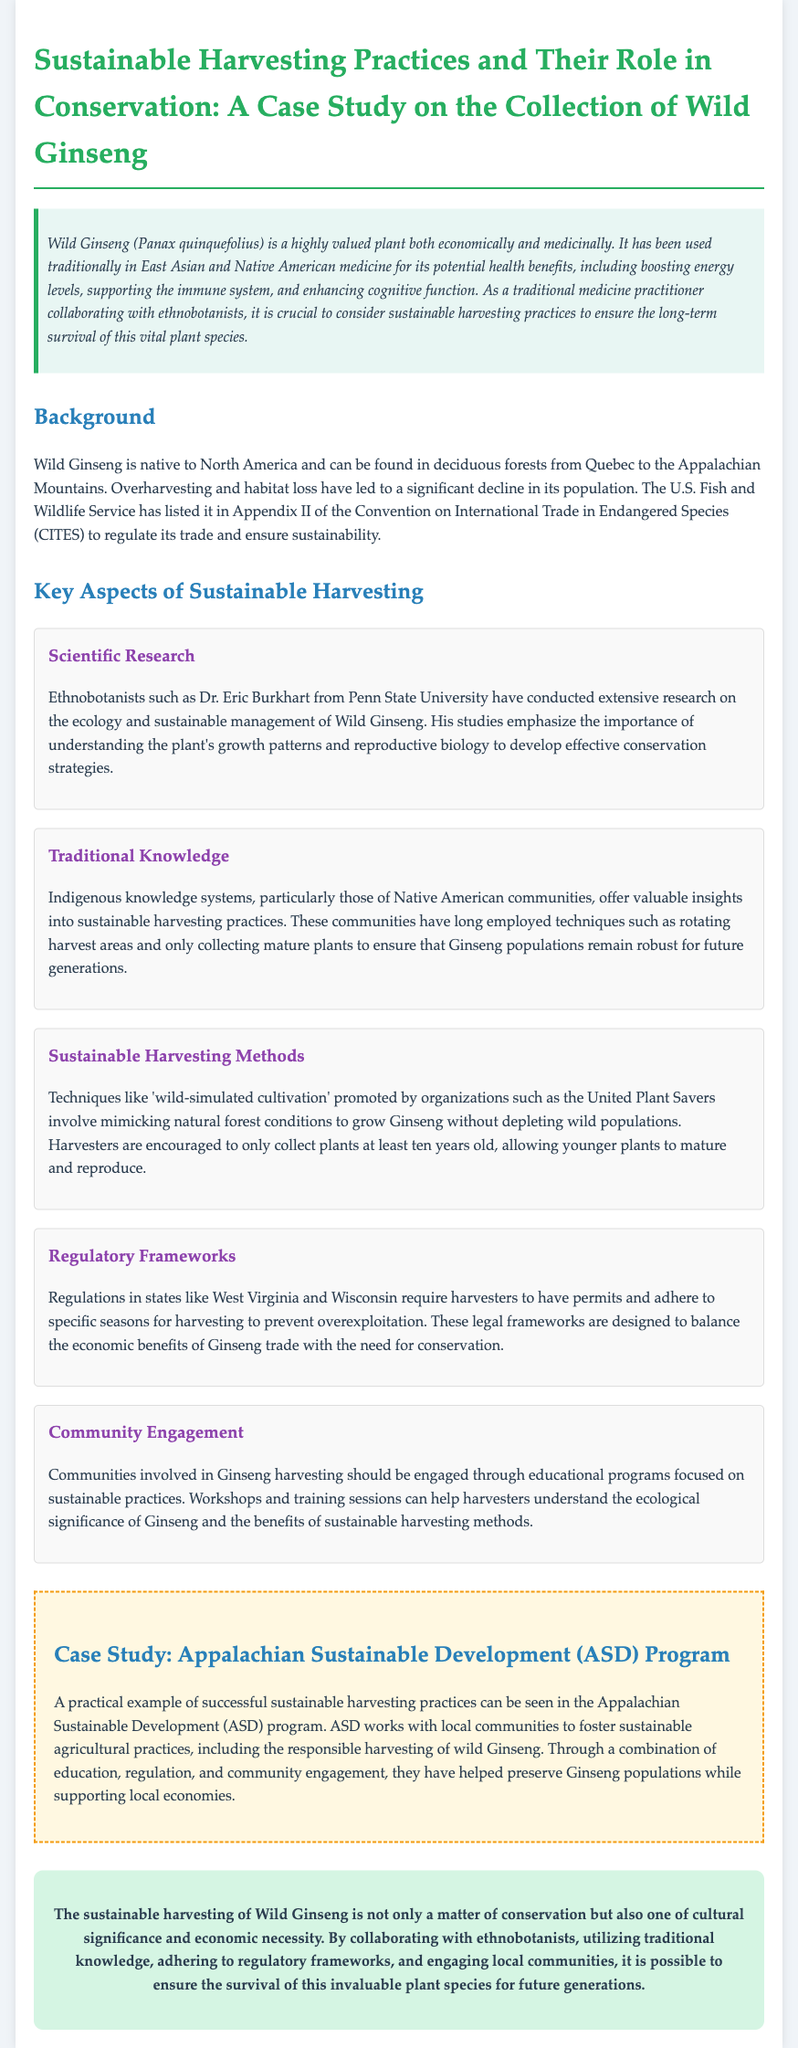What is the scientific name of Wild Ginseng? The scientific name mentioned in the document is Panax quinquefolius.
Answer: Panax quinquefolius Who conducted extensive research on Wild Ginseng? The document states that Dr. Eric Burkhart from Penn State University conducted research on Wild Ginseng.
Answer: Dr. Eric Burkhart What kind of techniques do Indigenous communities use for sustainable harvesting? The document highlights techniques such as rotating harvest areas and only collecting mature plants.
Answer: Rotating harvest areas and only collecting mature plants What is a sustainable harvesting method promoted by United Plant Savers? The document mentions 'wild-simulated cultivation' as a sustainable harvesting method.
Answer: Wild-simulated cultivation Which regulatory bodies control the harvesting of Wild Ginseng? The document refers to regulations in states like West Virginia and Wisconsin regarding Ginseng harvesting.
Answer: West Virginia and Wisconsin What organization works with local communities for sustainable Ginseng harvesting? The document provides the example of the Appalachian Sustainable Development (ASD) program for sustainable practices.
Answer: Appalachian Sustainable Development (ASD) Why is sustainable harvesting of Wild Ginseng culturally significant? The document states that it is a matter of cultural significance and economic necessity.
Answer: Cultural significance and economic necessity What has contributed to the decline of Wild Ginseng's population? The document explains that overharvesting and habitat loss have led to the decline.
Answer: Overharvesting and habitat loss 